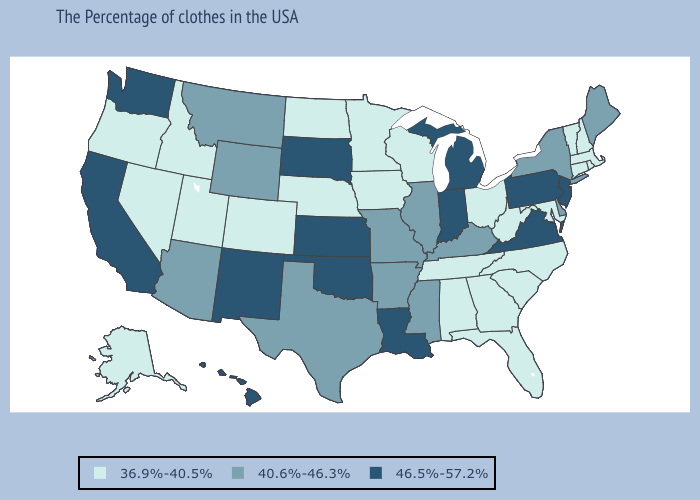Among the states that border Colorado , which have the lowest value?
Quick response, please. Nebraska, Utah. Name the states that have a value in the range 46.5%-57.2%?
Keep it brief. New Jersey, Pennsylvania, Virginia, Michigan, Indiana, Louisiana, Kansas, Oklahoma, South Dakota, New Mexico, California, Washington, Hawaii. Is the legend a continuous bar?
Keep it brief. No. Does Colorado have the same value as Indiana?
Write a very short answer. No. Name the states that have a value in the range 36.9%-40.5%?
Write a very short answer. Massachusetts, Rhode Island, New Hampshire, Vermont, Connecticut, Maryland, North Carolina, South Carolina, West Virginia, Ohio, Florida, Georgia, Alabama, Tennessee, Wisconsin, Minnesota, Iowa, Nebraska, North Dakota, Colorado, Utah, Idaho, Nevada, Oregon, Alaska. Among the states that border Vermont , does New Hampshire have the highest value?
Be succinct. No. How many symbols are there in the legend?
Give a very brief answer. 3. Does Idaho have the highest value in the USA?
Keep it brief. No. Does Oklahoma have the highest value in the USA?
Quick response, please. Yes. Does Massachusetts have the highest value in the USA?
Be succinct. No. Name the states that have a value in the range 36.9%-40.5%?
Give a very brief answer. Massachusetts, Rhode Island, New Hampshire, Vermont, Connecticut, Maryland, North Carolina, South Carolina, West Virginia, Ohio, Florida, Georgia, Alabama, Tennessee, Wisconsin, Minnesota, Iowa, Nebraska, North Dakota, Colorado, Utah, Idaho, Nevada, Oregon, Alaska. Name the states that have a value in the range 40.6%-46.3%?
Write a very short answer. Maine, New York, Delaware, Kentucky, Illinois, Mississippi, Missouri, Arkansas, Texas, Wyoming, Montana, Arizona. What is the lowest value in states that border Kansas?
Be succinct. 36.9%-40.5%. Name the states that have a value in the range 40.6%-46.3%?
Keep it brief. Maine, New York, Delaware, Kentucky, Illinois, Mississippi, Missouri, Arkansas, Texas, Wyoming, Montana, Arizona. What is the value of Oklahoma?
Answer briefly. 46.5%-57.2%. 